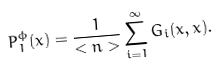<formula> <loc_0><loc_0><loc_500><loc_500>P _ { 1 } ^ { \phi } ( x ) = \frac { 1 } { < n > } \sum _ { i = 1 } ^ { \infty } G _ { i } ( x , x ) .</formula> 